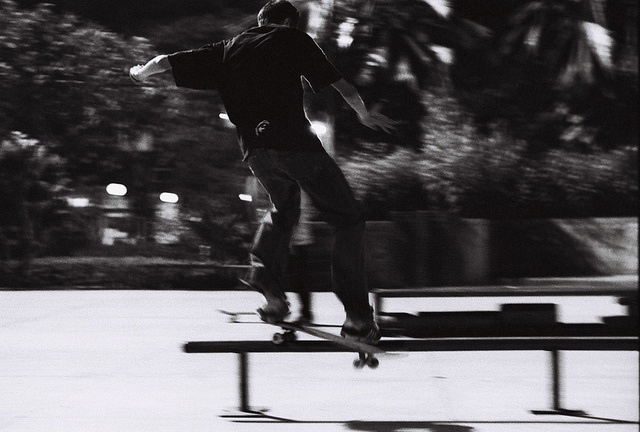Describe the objects in this image and their specific colors. I can see people in black, gray, darkgray, and lightgray tones, bench in black, gray, darkgray, and lightgray tones, bench in black, lightgray, darkgray, and gray tones, bench in black, gray, and darkgray tones, and skateboard in black, gray, darkgray, and lightgray tones in this image. 